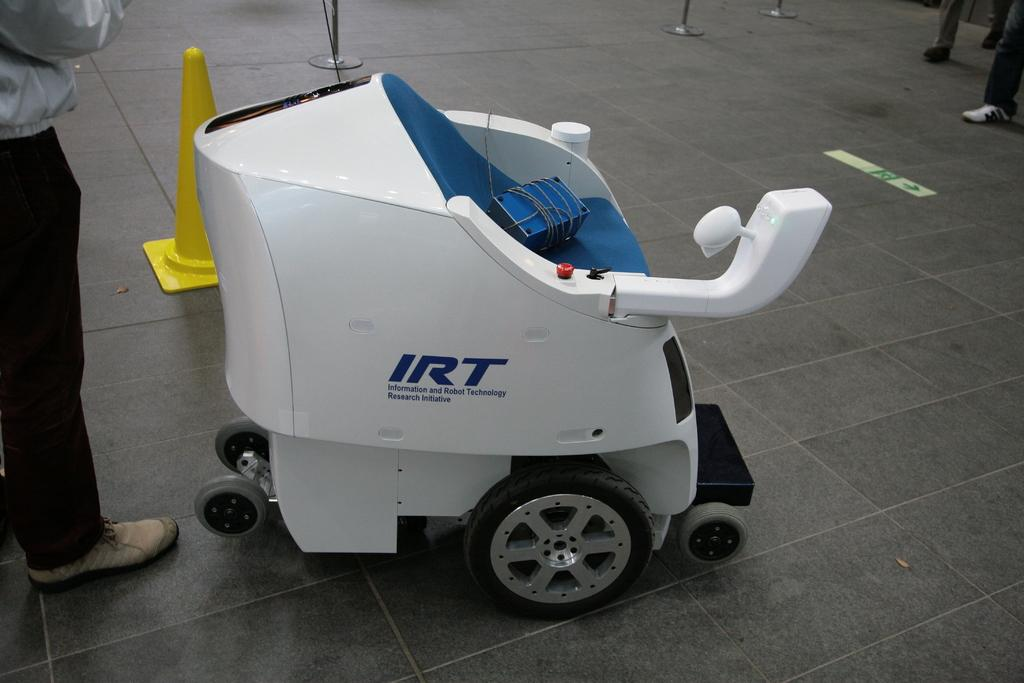<image>
Describe the image concisely. a machine that has IRT written on the side of it 